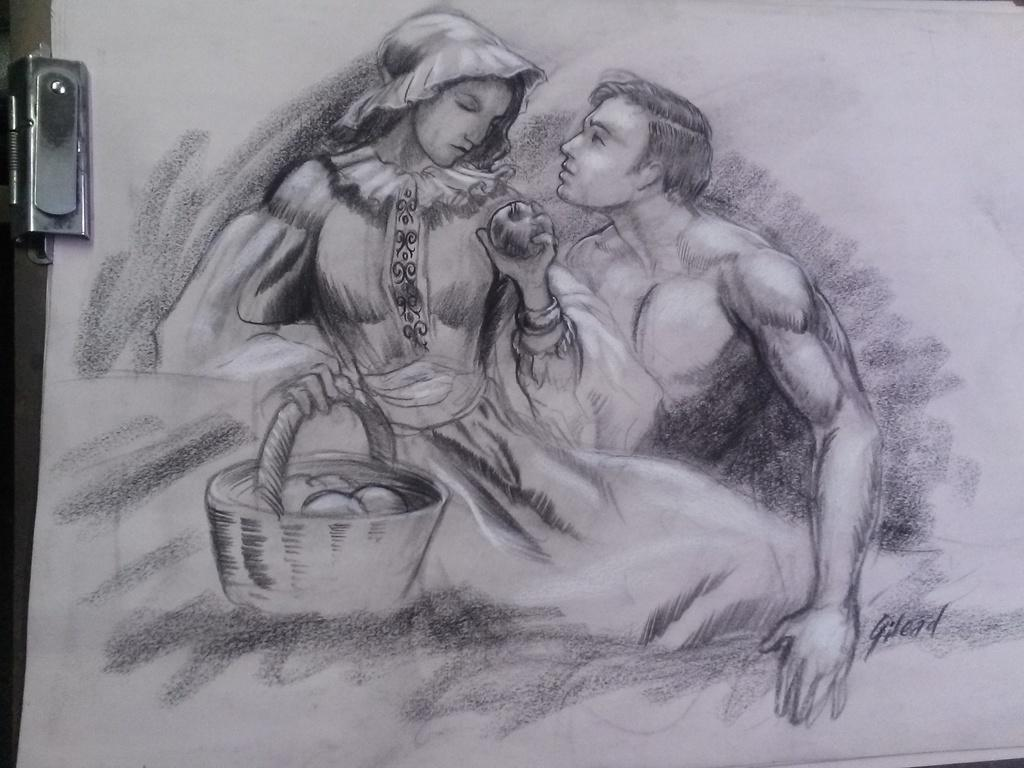What is depicted on the paper in the image? There is there a painting on paper in the image? How many people are present in the image? There are two persons in the image. What is the purpose of the basket in the image? The purpose of the basket is not clear from the image, but it might be used for carrying or storing something. What type of fruit can be seen in the image? There is a fruit in the image, but the specific type is not mentioned. Can you describe the object on the left side of the image? There is an object on the left side of the image, but its exact nature is not clear from the provided facts. Can you tell me how many rings are being worn by the persons in the image? There is no mention of rings or any jewelry in the image, so it is not possible to answer this question. Are there any snakes visible in the image? There is no mention of snakes or any animals in the image, so it is not possible to answer this question. 